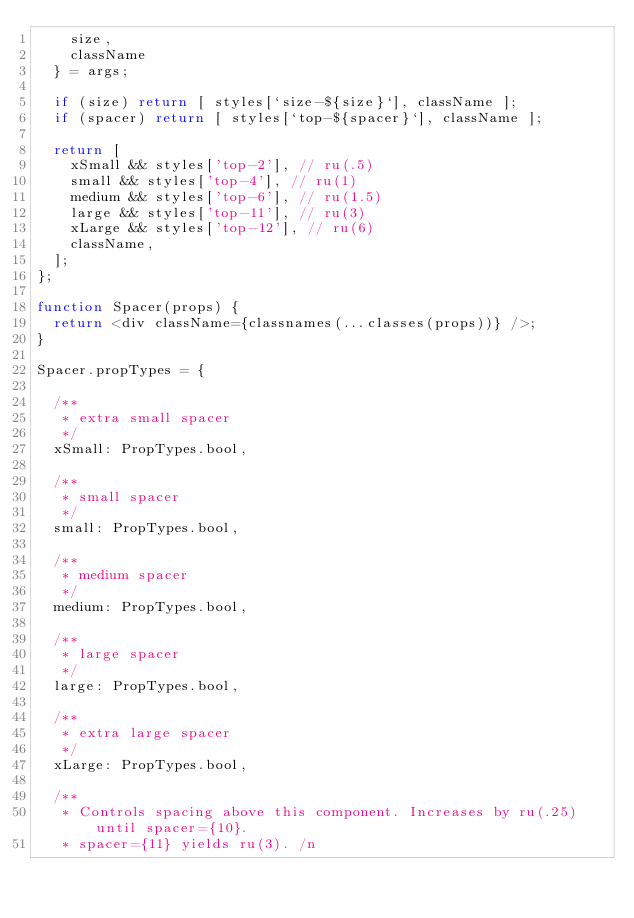Convert code to text. <code><loc_0><loc_0><loc_500><loc_500><_JavaScript_>    size,
    className
  } = args;

  if (size) return [ styles[`size-${size}`], className ];
  if (spacer) return [ styles[`top-${spacer}`], className ];

  return [
    xSmall && styles['top-2'], // ru(.5)
    small && styles['top-4'], // ru(1)
    medium && styles['top-6'], // ru(1.5)
    large && styles['top-11'], // ru(3)
    xLarge && styles['top-12'], // ru(6)
    className,
  ];
};

function Spacer(props) {
  return <div className={classnames(...classes(props))} />;
}

Spacer.propTypes = {

  /**
   * extra small spacer
   */
  xSmall: PropTypes.bool,

  /**
   * small spacer
   */
  small: PropTypes.bool,

  /**
   * medium spacer
   */
  medium: PropTypes.bool,

  /**
   * large spacer
   */
  large: PropTypes.bool,

  /**
   * extra large spacer
   */
  xLarge: PropTypes.bool,

  /**
   * Controls spacing above this component. Increases by ru(.25) until spacer={10}.
   * spacer={11} yields ru(3). /n</code> 